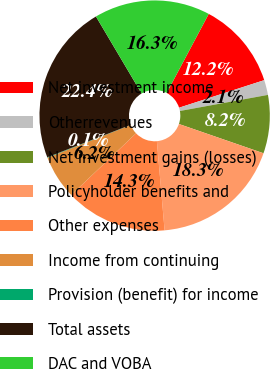<chart> <loc_0><loc_0><loc_500><loc_500><pie_chart><fcel>Net investment income<fcel>Otherrevenues<fcel>Net investment gains (losses)<fcel>Policyholder benefits and<fcel>Other expenses<fcel>Income from continuing<fcel>Provision (benefit) for income<fcel>Total assets<fcel>DAC and VOBA<nl><fcel>12.24%<fcel>2.1%<fcel>8.18%<fcel>18.32%<fcel>14.27%<fcel>6.15%<fcel>0.07%<fcel>22.38%<fcel>16.29%<nl></chart> 